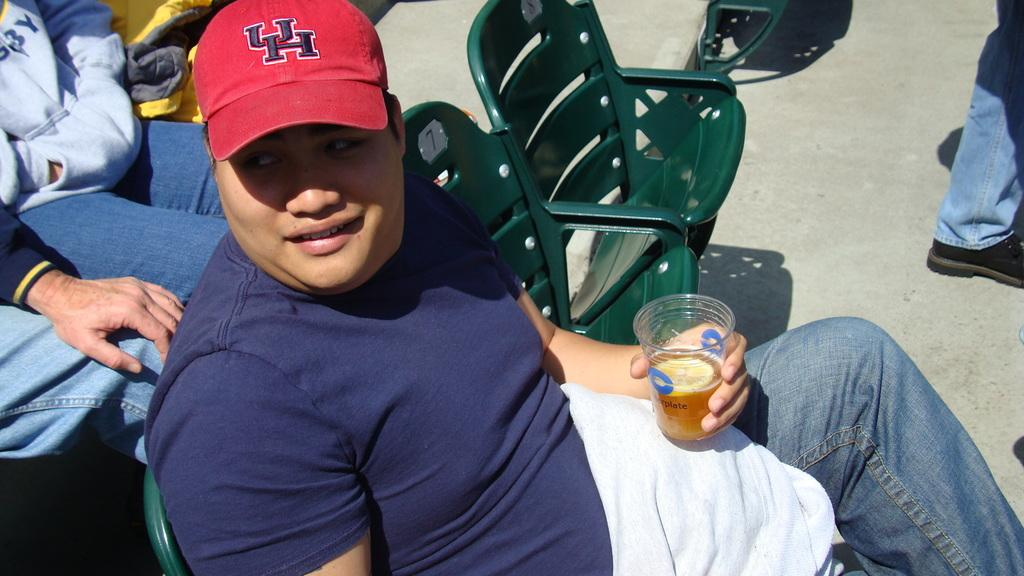What are the people in the image doing? The people in the image are sitting. Can you describe the describe the man in the center of the image? The man in the center of the image is sitting and holding a wine glass. What type of furniture can be seen in the image? Chairs can be seen in the image. What part of a person's body is visible on the right side of the image? A person's leg is visible on the right side of the image. Are there any pets visible on the seashore in the image? There is no seashore or pets present in the image. What type of furniture is being used by the people to walk on the beach? There is no furniture or beach present in the image, and the people are sitting on chairs. 